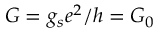Convert formula to latex. <formula><loc_0><loc_0><loc_500><loc_500>G = g _ { s } e ^ { 2 } / h = G _ { 0 }</formula> 